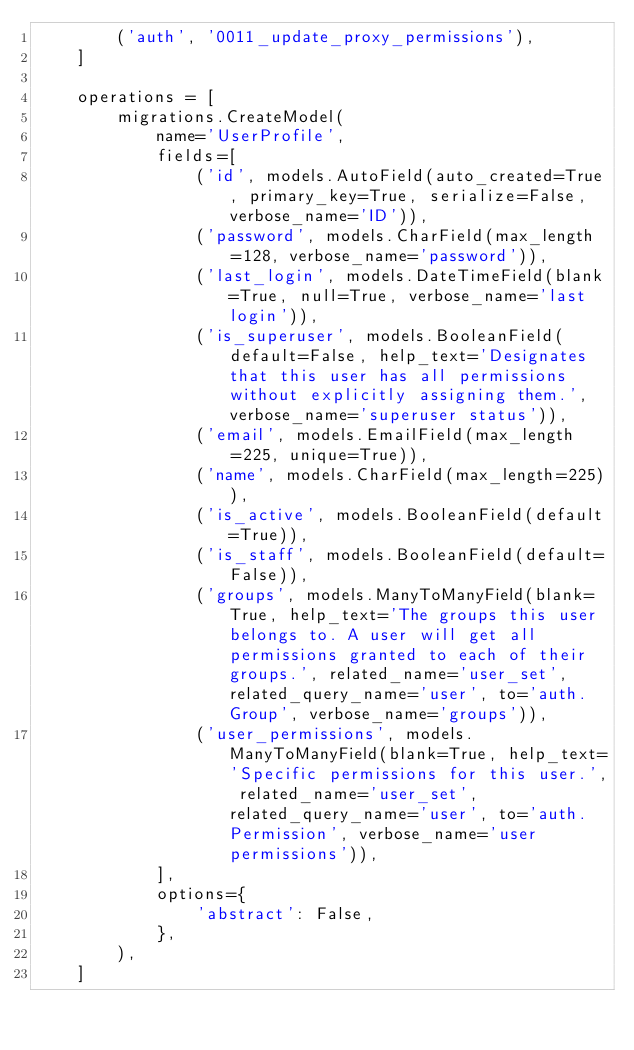<code> <loc_0><loc_0><loc_500><loc_500><_Python_>        ('auth', '0011_update_proxy_permissions'),
    ]

    operations = [
        migrations.CreateModel(
            name='UserProfile',
            fields=[
                ('id', models.AutoField(auto_created=True, primary_key=True, serialize=False, verbose_name='ID')),
                ('password', models.CharField(max_length=128, verbose_name='password')),
                ('last_login', models.DateTimeField(blank=True, null=True, verbose_name='last login')),
                ('is_superuser', models.BooleanField(default=False, help_text='Designates that this user has all permissions without explicitly assigning them.', verbose_name='superuser status')),
                ('email', models.EmailField(max_length=225, unique=True)),
                ('name', models.CharField(max_length=225)),
                ('is_active', models.BooleanField(default=True)),
                ('is_staff', models.BooleanField(default=False)),
                ('groups', models.ManyToManyField(blank=True, help_text='The groups this user belongs to. A user will get all permissions granted to each of their groups.', related_name='user_set', related_query_name='user', to='auth.Group', verbose_name='groups')),
                ('user_permissions', models.ManyToManyField(blank=True, help_text='Specific permissions for this user.', related_name='user_set', related_query_name='user', to='auth.Permission', verbose_name='user permissions')),
            ],
            options={
                'abstract': False,
            },
        ),
    ]
</code> 